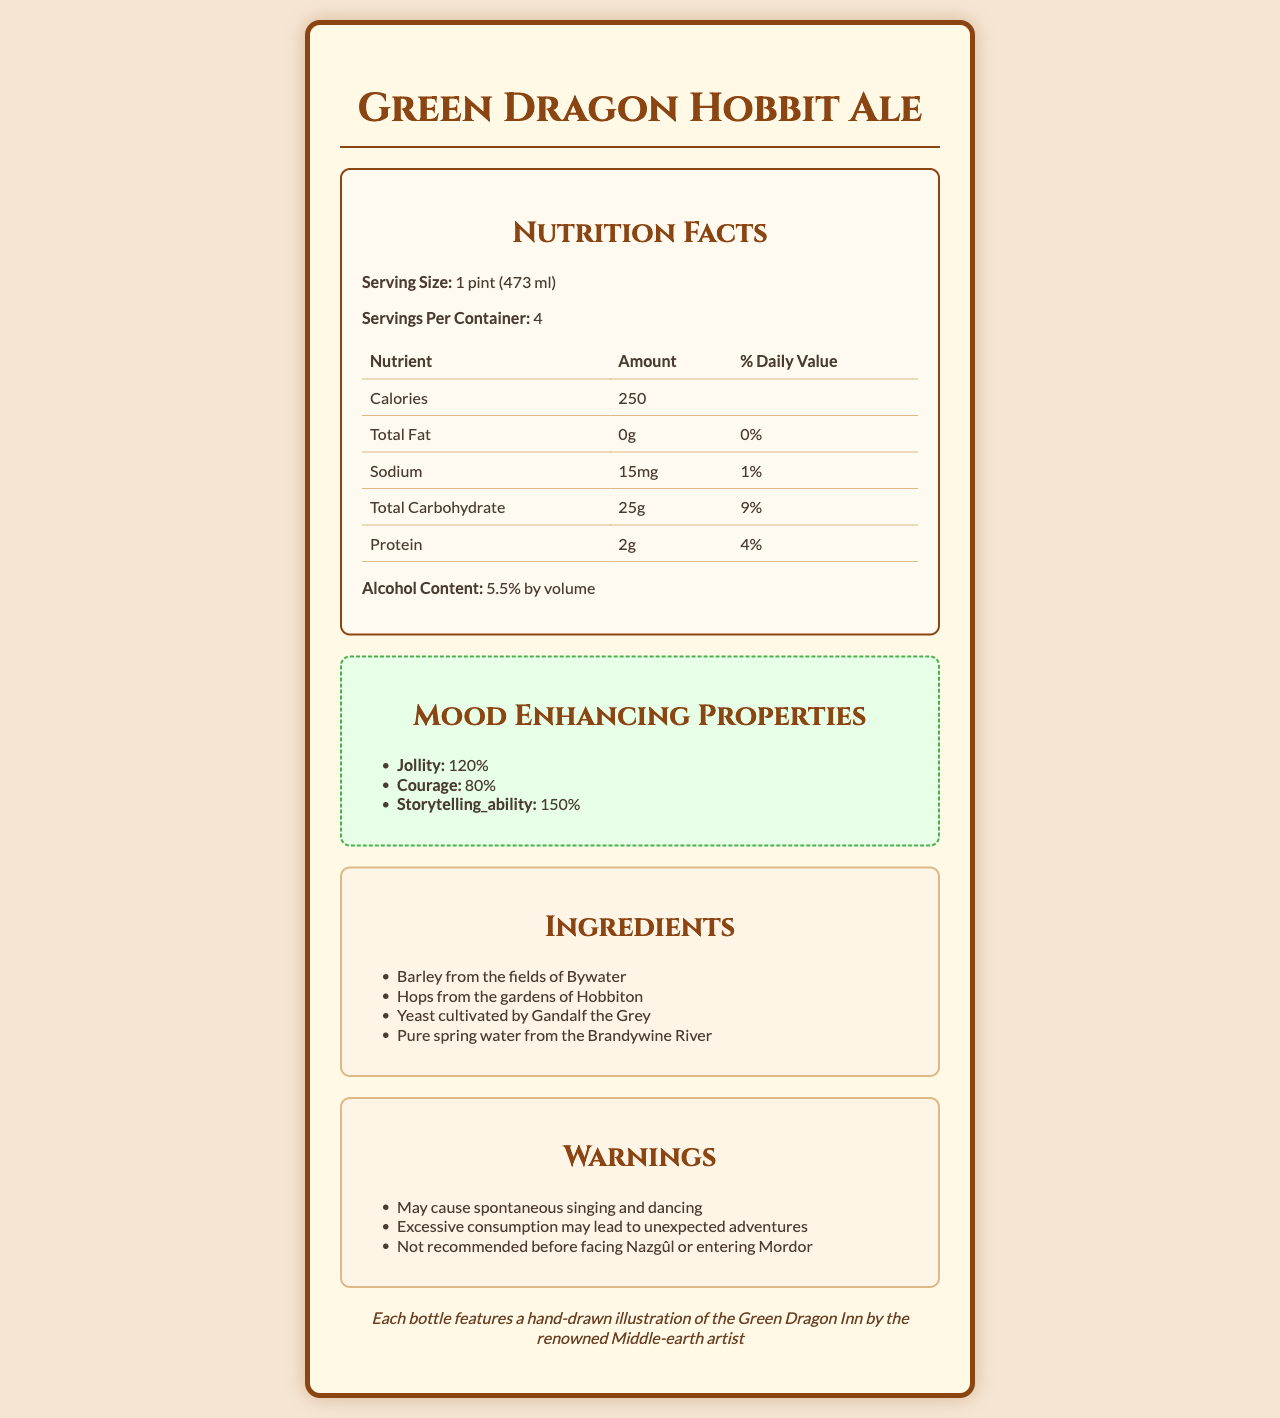what is the serving size? The serving size is clearly mentioned under the Nutrition Facts section.
Answer: 1 pint (473 ml) how many servings are in each container? According to the Nutrition Facts, there are 4 servings per container.
Answer: 4 how many calories are in one serving? The Nutrition Facts lists the calorie content as 250 per serving.
Answer: 250 what mainly contributes to the aroma of Hobbit Ale? The additional info section mentions that the aroma consists of notes of pipeweed and freshly baked seedcake.
Answer: Notes of pipeweed and freshly baked seedcake how much protein does Hobbit Ale provide per serving? Under the Nutrition Facts, protein content per serving is listed as 2g.
Answer: 2g what kind of properties does Hobbit Ale enhance? In the Mood Enhancing Properties section, these properties are listed.
Answer: Jollity, courage, and storytelling ability what is Hobbit Ale's main color? The additional info section states that the color is golden amber, reminiscent of autumn leaves in Lothlorien.
Answer: Golden amber what is the total carbohydrate content per serving? A. 25g B. 15g C. 10g D. 30g The Nutrition Facts label lists the total carbohydrate content as 25g.
Answer: A. 25g which of the following is an ingredient in Hobbit Ale? I. Barley from the fields of Bywater II. Imported wheat III. Elven nectar IV. Pure spring water from the Brandywine River Only these ingredients are mentioned in the Ingredients section.
Answer: I. Barley from the fields of Bywater, IV. Pure spring water from the Brandywine River is Hobbit Ale recommended to be used before facing Nazgûl or entering Mordor? One of the warnings specifically advises against consuming before facing Nazgûl or entering Mordor.
Answer: No does Hobbit Ale contain any fats? The total fat content is listed as 0g, which means there are no fats.
Answer: No how should Hobbit Ale be stored? The storage instructions advise keeping it cool in the cellars of Bag End.
Answer: Best kept cool in the cellars of Bag End what is the main idea of the document? The document covers all aspects related to the Green Dragon Hobbit Ale, focusing on its nutritious content, unique ingredients, mood-enhancing properties, and special notes for storage and consumption.
Answer: The document provides comprehensive details about Green Dragon Hobbit Ale, including its nutrition facts, mood-enhancing properties, ingredients, and other special features. where is the barley sourced from? The document just states "Barley from the fields of Bywater," but does not specify more details about its sourcing process.
Answer: Cannot be determined 